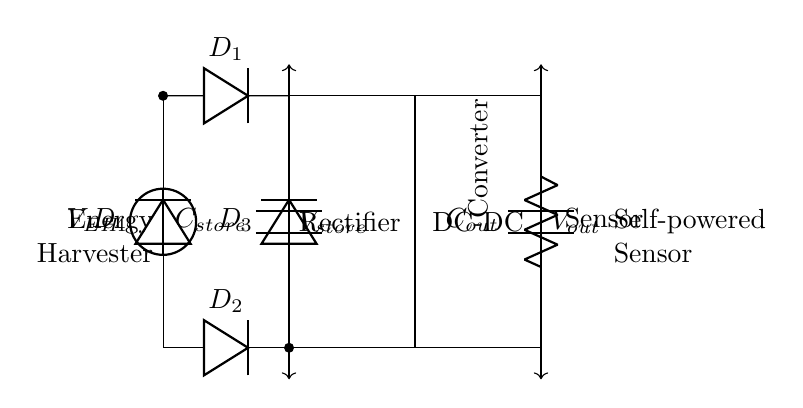What is the voltage source in this circuit? The voltage source in this circuit is labeled as V_EH, which stands for the energy harvesting voltage. It is positioned at the top left of the circuit diagram, indicating the input voltage supply.
Answer: V_EH How many diodes are present in this circuit? The circuit contains four diodes labeled D1, D2, D3, and D4. They are used for rectification purposes and are clearly marked in the diagram, adding to the overall components of the energy harvesting circuit.
Answer: Four What is the function of the capacitor labeled C_store? C_store, or the storage capacitor, serves to store electrical energy harvested from the voltage source. It connects directly in parallel with the diodes, allowing it to collect and maintain the charge necessary for the operation of the subsequent components, particularly the DC-DC converter.
Answer: Store energy What is the output component of the circuit? The output component of the circuit is indicated as C_out, which is the output capacitor. It is located at the far right side of the circuit and is used to smooth the output voltage supplied to the sensor, ensuring stable performance.
Answer: C_out What is the role of the DC-DC converter? The DC-DC converter is responsible for converting the input voltage from the energy harvesting source (V_EH) to the required voltage level for the load (sensor). It is situated between the storage capacitor and the output capacitor, indicating its role in regulating voltage to match the sensor's requirements.
Answer: Regulate voltage What voltage is indicated across V_store? V_store is the voltage across the storage capacitor (C_store) and is indicated in the circuit as the potential difference between the top and bottom connections of the capacitor. This would reflect the charge accumulated in C_store from the harvested energy.
Answer: V_store What does the "Sensor" label indicate in this circuit? The "Sensor" label denotes the load that will utilize the harvested energy provided by the energy harvesting circuit. It connects directly to the output capacitor C_out, indicating that it operates based on the energy processed through the previous components of the circuit.
Answer: Load device 